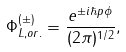<formula> <loc_0><loc_0><loc_500><loc_500>\Phi _ { L , o r . } ^ { ( \pm ) } = \frac { e ^ { \pm i \hbar { p } \phi } } { ( 2 \pi ) ^ { 1 / 2 } } ,</formula> 